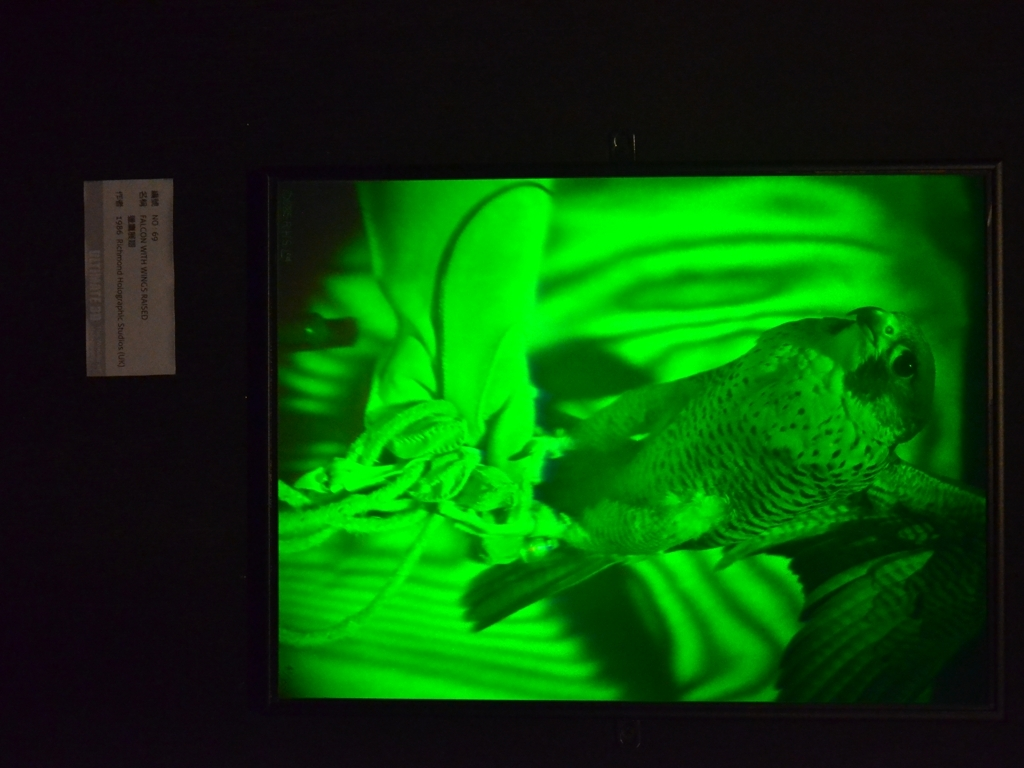What is the predominant color in the image, and what mood does it evoke? The predominant color in this image is green, which can evoke feelings of growth, harmony, and freshness. It gives the image an otherworldly or surreal quality, potentially suggesting a connection to nature or emphasizing the liveliness of the subject. 